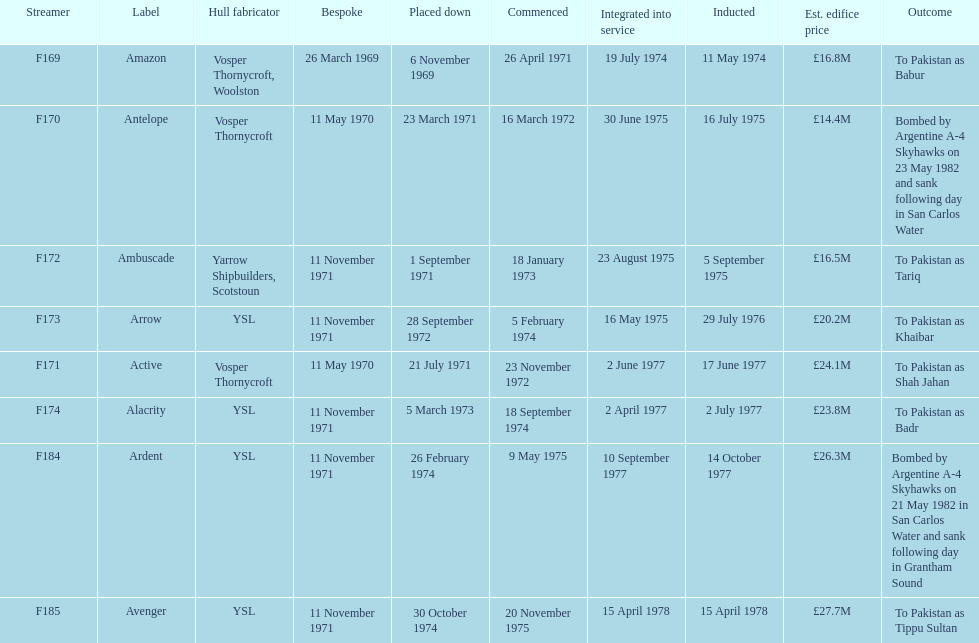What is the name of the ship listed after ardent? Avenger. 